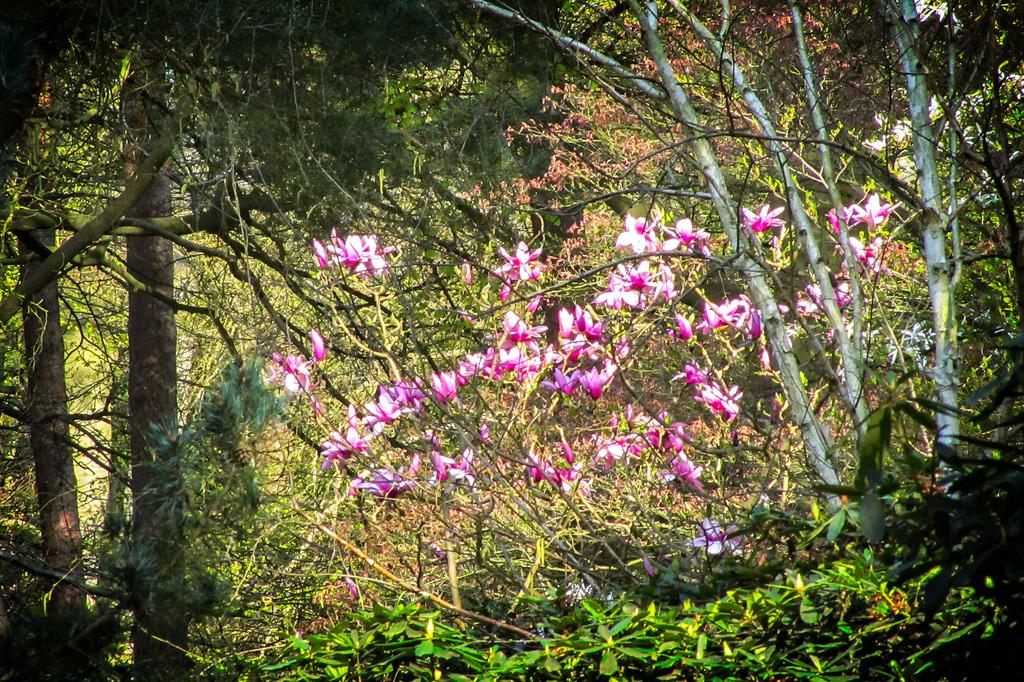What type of vegetation can be seen in the image? There are trees in the image. What type of flora can be seen in addition to the trees? There are flowers in the image. Can you spot a toad hopping among the flowers in the image? There is no toad present in the image. What type of industrial machinery can be seen in the image? There is no industrial machinery present in the image; it features trees and flowers. 